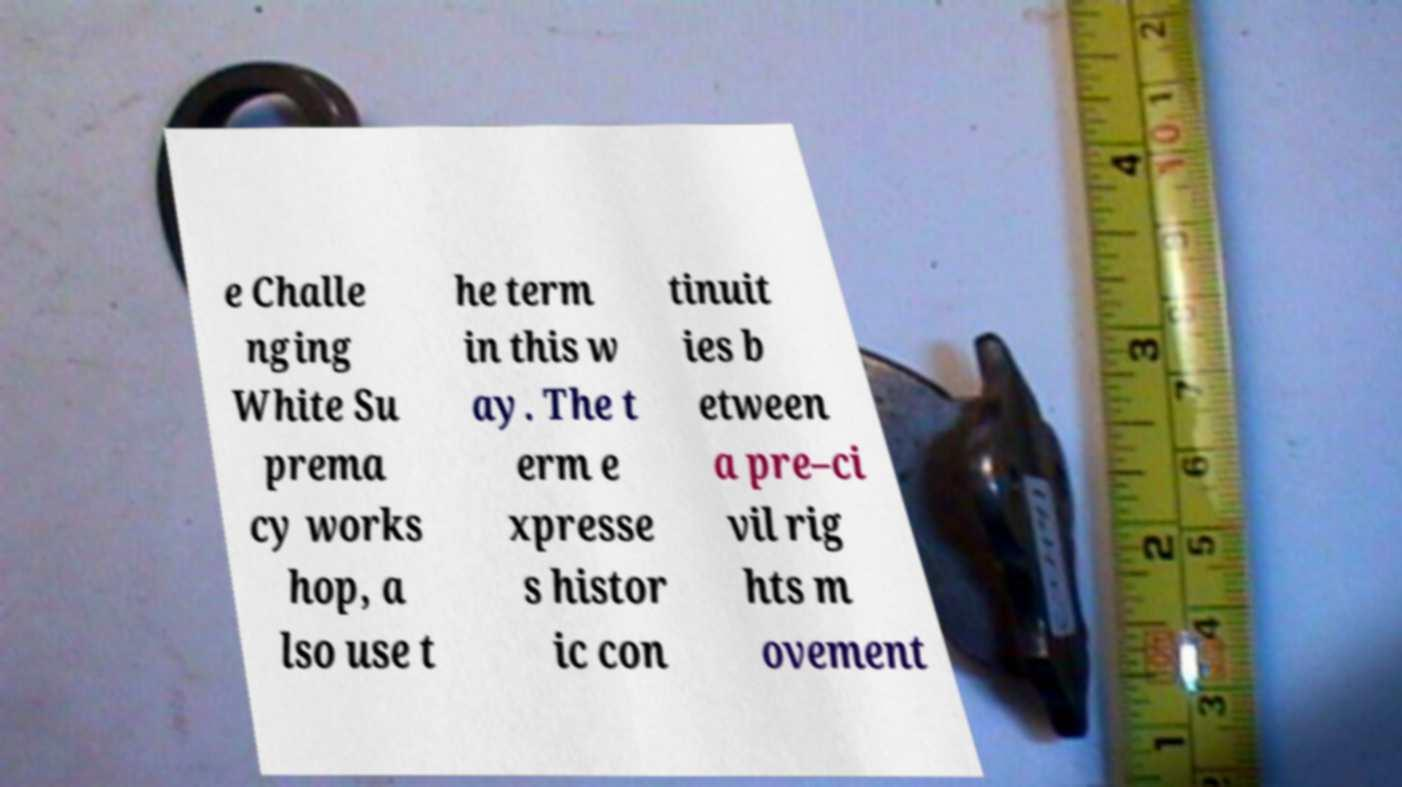Could you extract and type out the text from this image? e Challe nging White Su prema cy works hop, a lso use t he term in this w ay. The t erm e xpresse s histor ic con tinuit ies b etween a pre–ci vil rig hts m ovement 